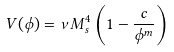Convert formula to latex. <formula><loc_0><loc_0><loc_500><loc_500>V ( \phi ) = \nu M _ { s } ^ { 4 } \left ( 1 - \frac { c } { \phi ^ { m } } \right )</formula> 